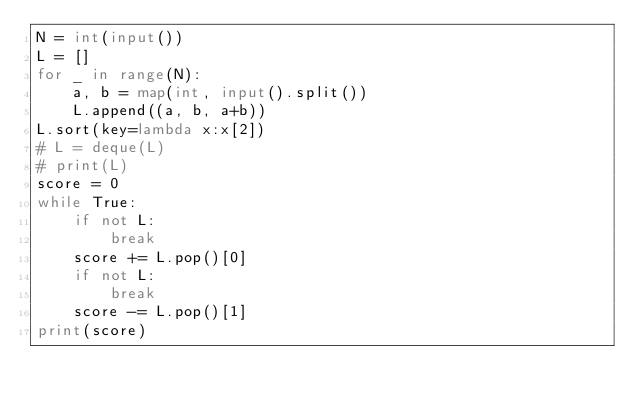Convert code to text. <code><loc_0><loc_0><loc_500><loc_500><_Python_>N = int(input())
L = []
for _ in range(N):
    a, b = map(int, input().split())
    L.append((a, b, a+b))
L.sort(key=lambda x:x[2])
# L = deque(L)
# print(L)
score = 0
while True:
    if not L:
        break
    score += L.pop()[0]
    if not L:
        break
    score -= L.pop()[1]
print(score)</code> 